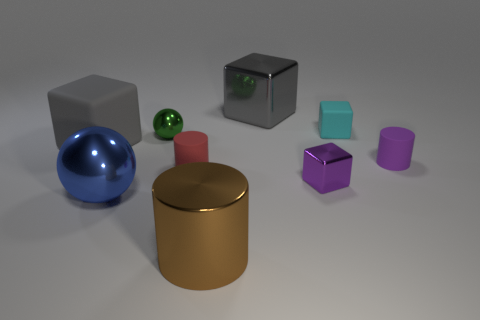How many objects are both behind the blue metal thing and left of the brown metal cylinder?
Your answer should be very brief. 3. What material is the small cyan thing?
Your response must be concise. Rubber. Is the number of large metallic balls in front of the blue shiny thing the same as the number of tiny yellow balls?
Provide a short and direct response. Yes. How many small red metal objects are the same shape as the gray metal thing?
Provide a succinct answer. 0. Does the large brown object have the same shape as the large blue object?
Provide a short and direct response. No. How many objects are either matte blocks in front of the cyan matte object or small purple metal things?
Make the answer very short. 2. There is a small metal thing right of the brown cylinder in front of the tiny rubber object that is to the left of the big shiny cylinder; what shape is it?
Your response must be concise. Cube. The red thing that is the same material as the cyan cube is what shape?
Provide a succinct answer. Cylinder. What is the size of the brown cylinder?
Your answer should be very brief. Large. Do the brown object and the green metallic thing have the same size?
Your answer should be compact. No. 